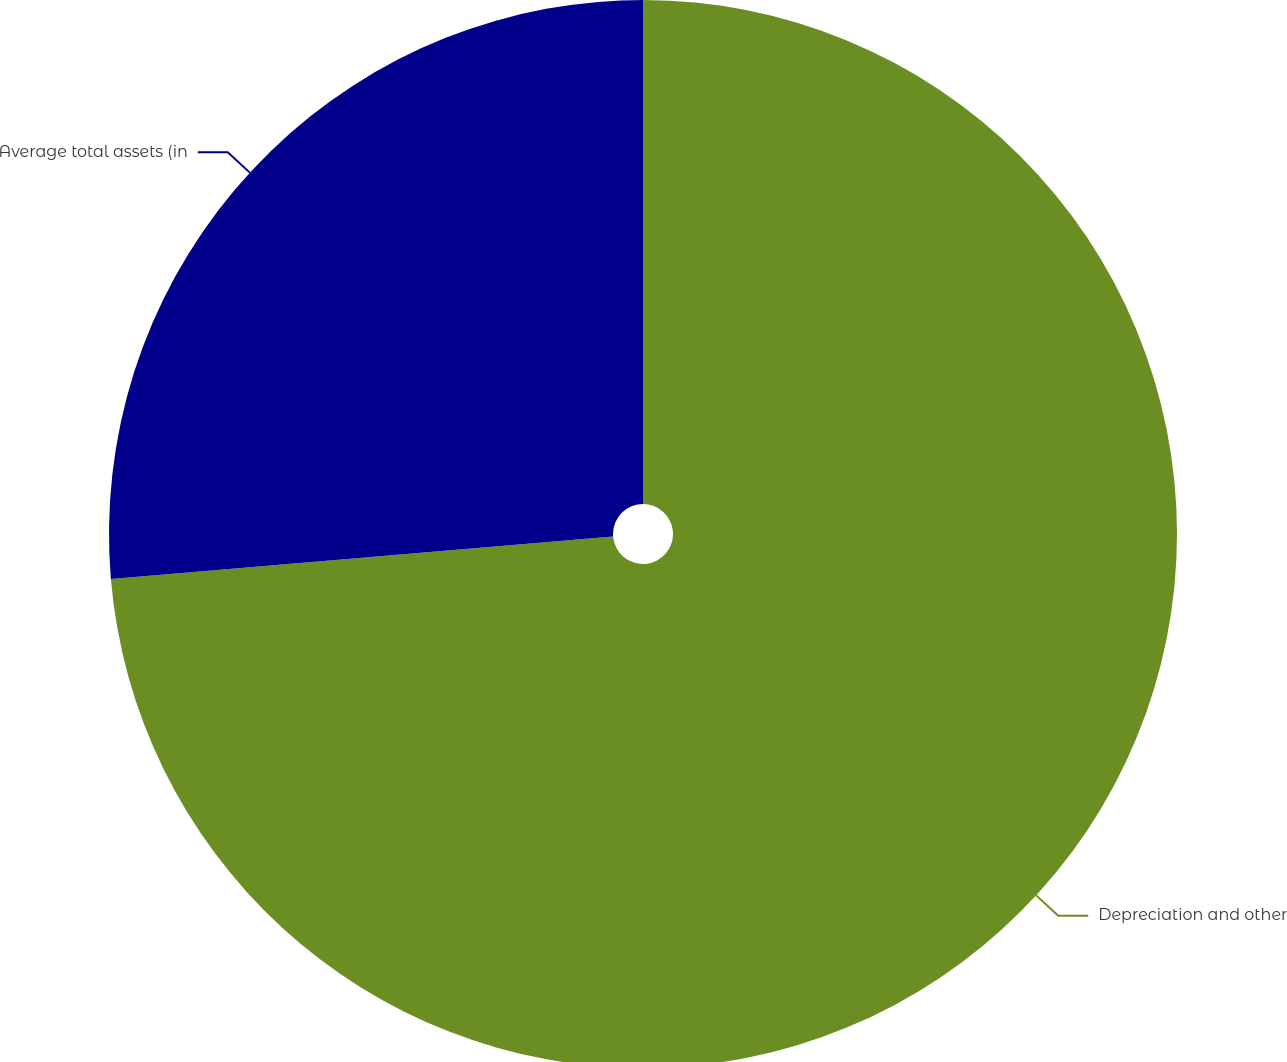Convert chart to OTSL. <chart><loc_0><loc_0><loc_500><loc_500><pie_chart><fcel>Depreciation and other<fcel>Average total assets (in<nl><fcel>73.66%<fcel>26.34%<nl></chart> 